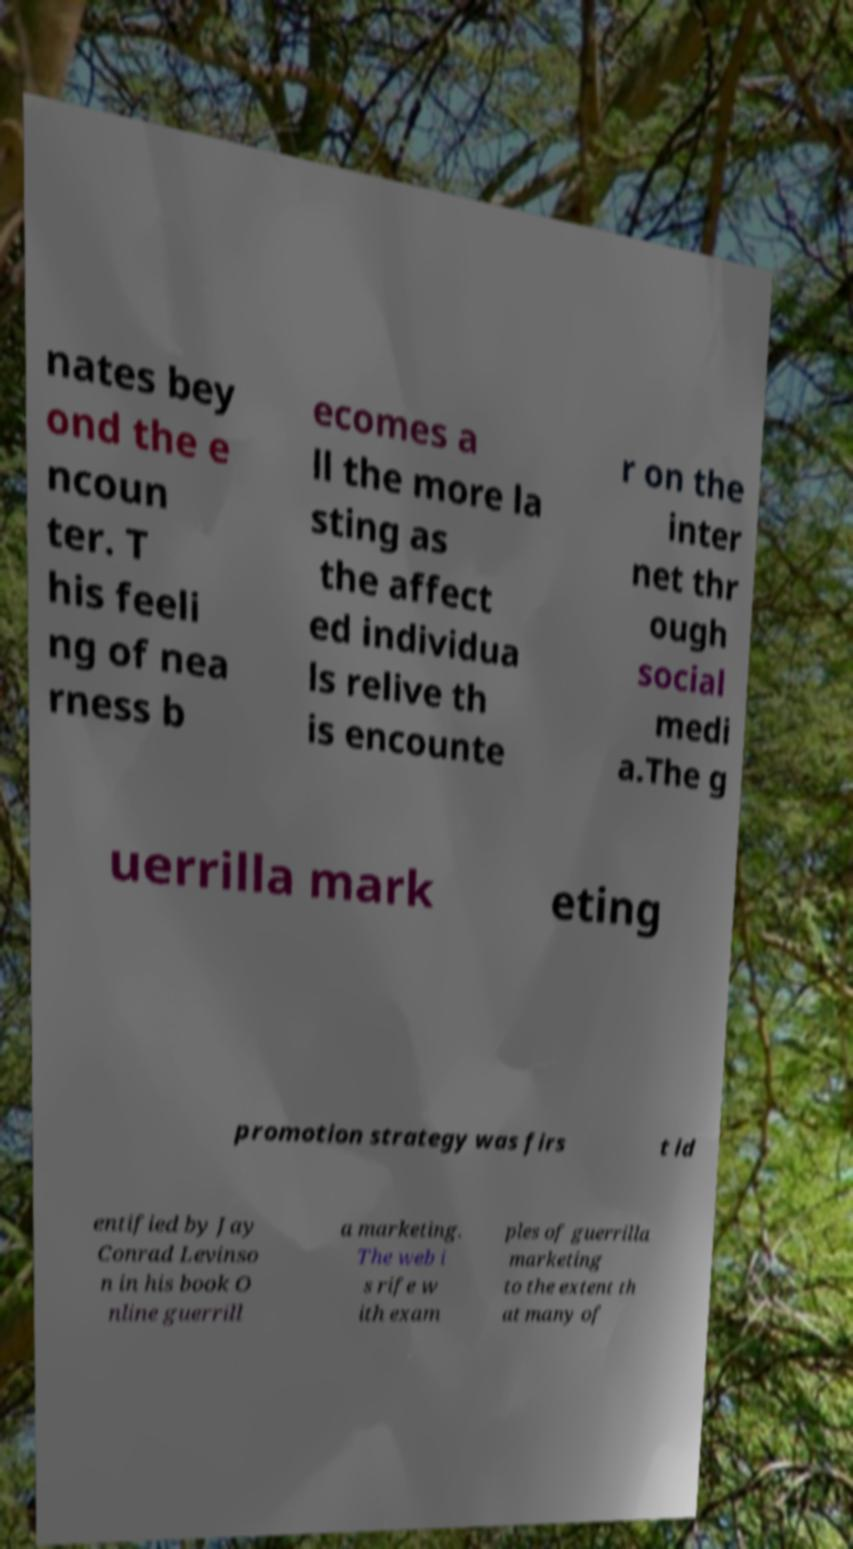Can you read and provide the text displayed in the image?This photo seems to have some interesting text. Can you extract and type it out for me? nates bey ond the e ncoun ter. T his feeli ng of nea rness b ecomes a ll the more la sting as the affect ed individua ls relive th is encounte r on the inter net thr ough social medi a.The g uerrilla mark eting promotion strategy was firs t id entified by Jay Conrad Levinso n in his book O nline guerrill a marketing. The web i s rife w ith exam ples of guerrilla marketing to the extent th at many of 